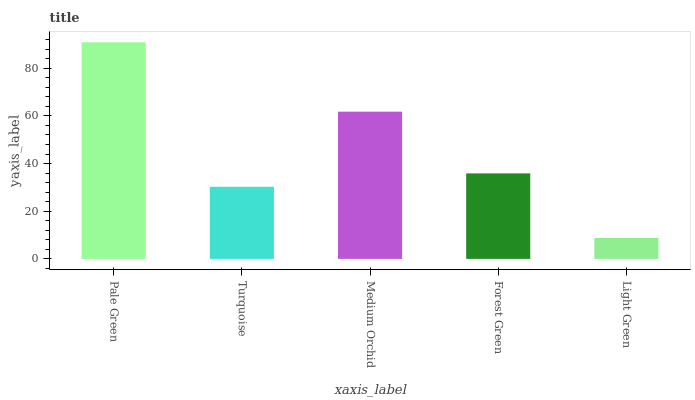Is Light Green the minimum?
Answer yes or no. Yes. Is Pale Green the maximum?
Answer yes or no. Yes. Is Turquoise the minimum?
Answer yes or no. No. Is Turquoise the maximum?
Answer yes or no. No. Is Pale Green greater than Turquoise?
Answer yes or no. Yes. Is Turquoise less than Pale Green?
Answer yes or no. Yes. Is Turquoise greater than Pale Green?
Answer yes or no. No. Is Pale Green less than Turquoise?
Answer yes or no. No. Is Forest Green the high median?
Answer yes or no. Yes. Is Forest Green the low median?
Answer yes or no. Yes. Is Pale Green the high median?
Answer yes or no. No. Is Medium Orchid the low median?
Answer yes or no. No. 